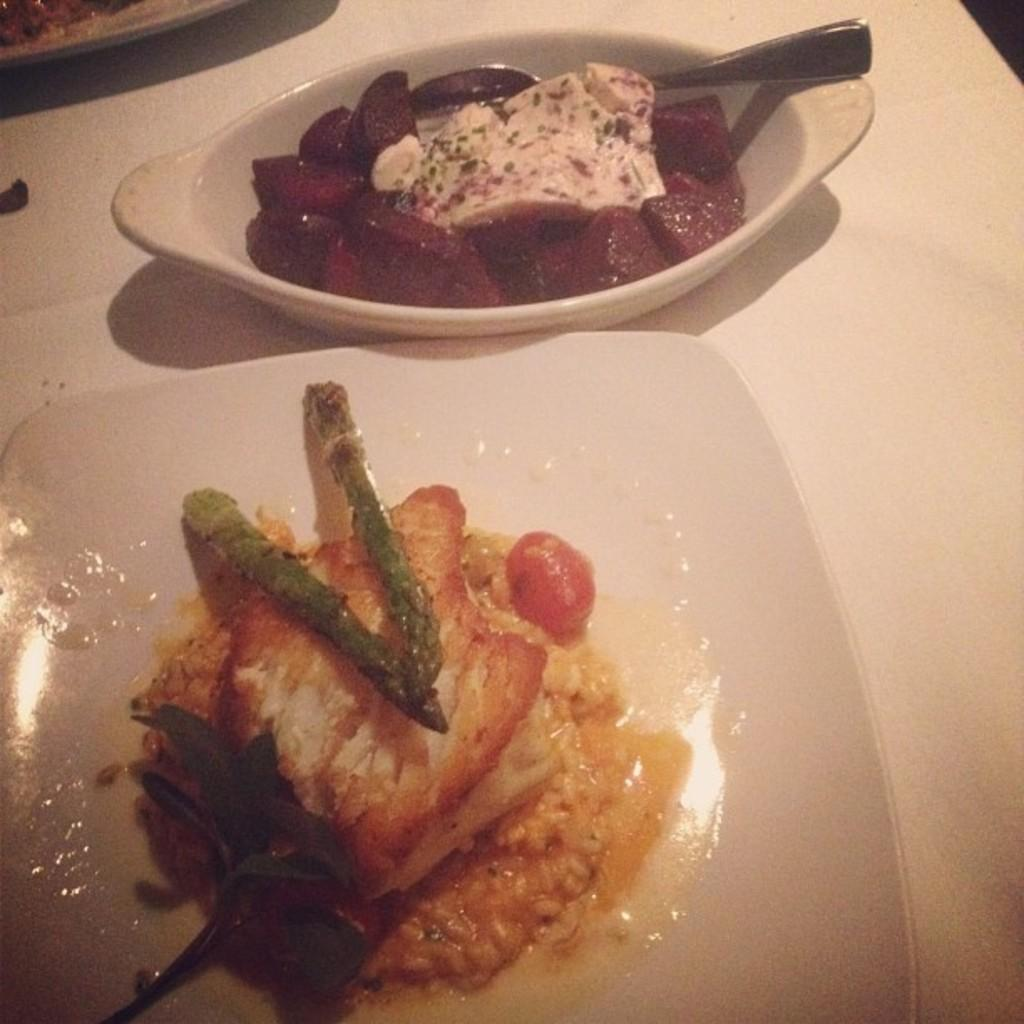What is the main feature of the big plate in the image? The big plate contains food. What type of food is on the big plate? The provided facts do not specify the type of food on the big plate. What is on the small plate in the image? The small plate contains sweet. What kind of sweet is on the small plate? The provided facts do not specify the type of sweet on the small plate. What utensil is present in the image? There is a spoon in the image. What type of substance is being used to play with the ball in the image? There is no ball present in the image; it only contains a big plate, a small plate, and a spoon. 